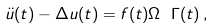<formula> <loc_0><loc_0><loc_500><loc_500>\ddot { u } ( t ) - \Delta u ( t ) = f ( t ) \Omega \ \Gamma ( t ) \, ,</formula> 